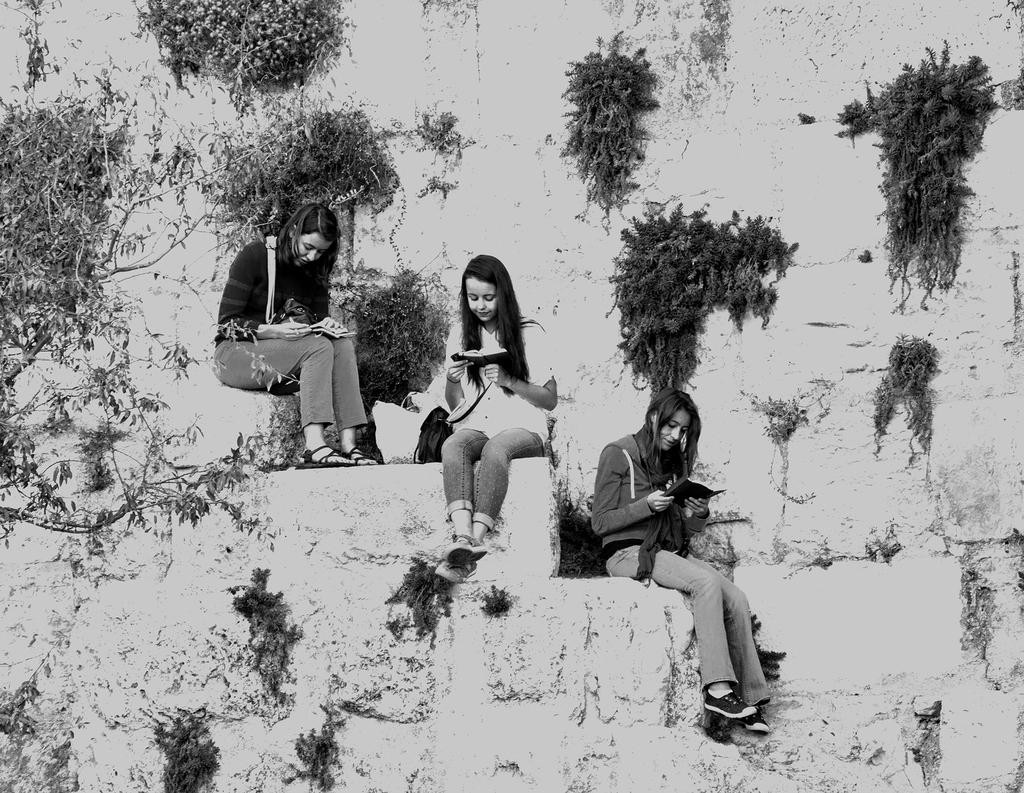What is the color scheme of the image? The image is black and white. How many girls are in the image? There are three girls in the image. Where are the girls sitting in the image? The girls are sitting on the stairs. What activity are the girls engaged in? The girls are reading books. What can be seen on the wall in the image? There are plants on the wall in the image. What news is the uncle sharing with the girls in the image? There is no uncle present in the image, and therefore no news can be shared. What type of waste is visible in the image? There is no waste visible in the image. 